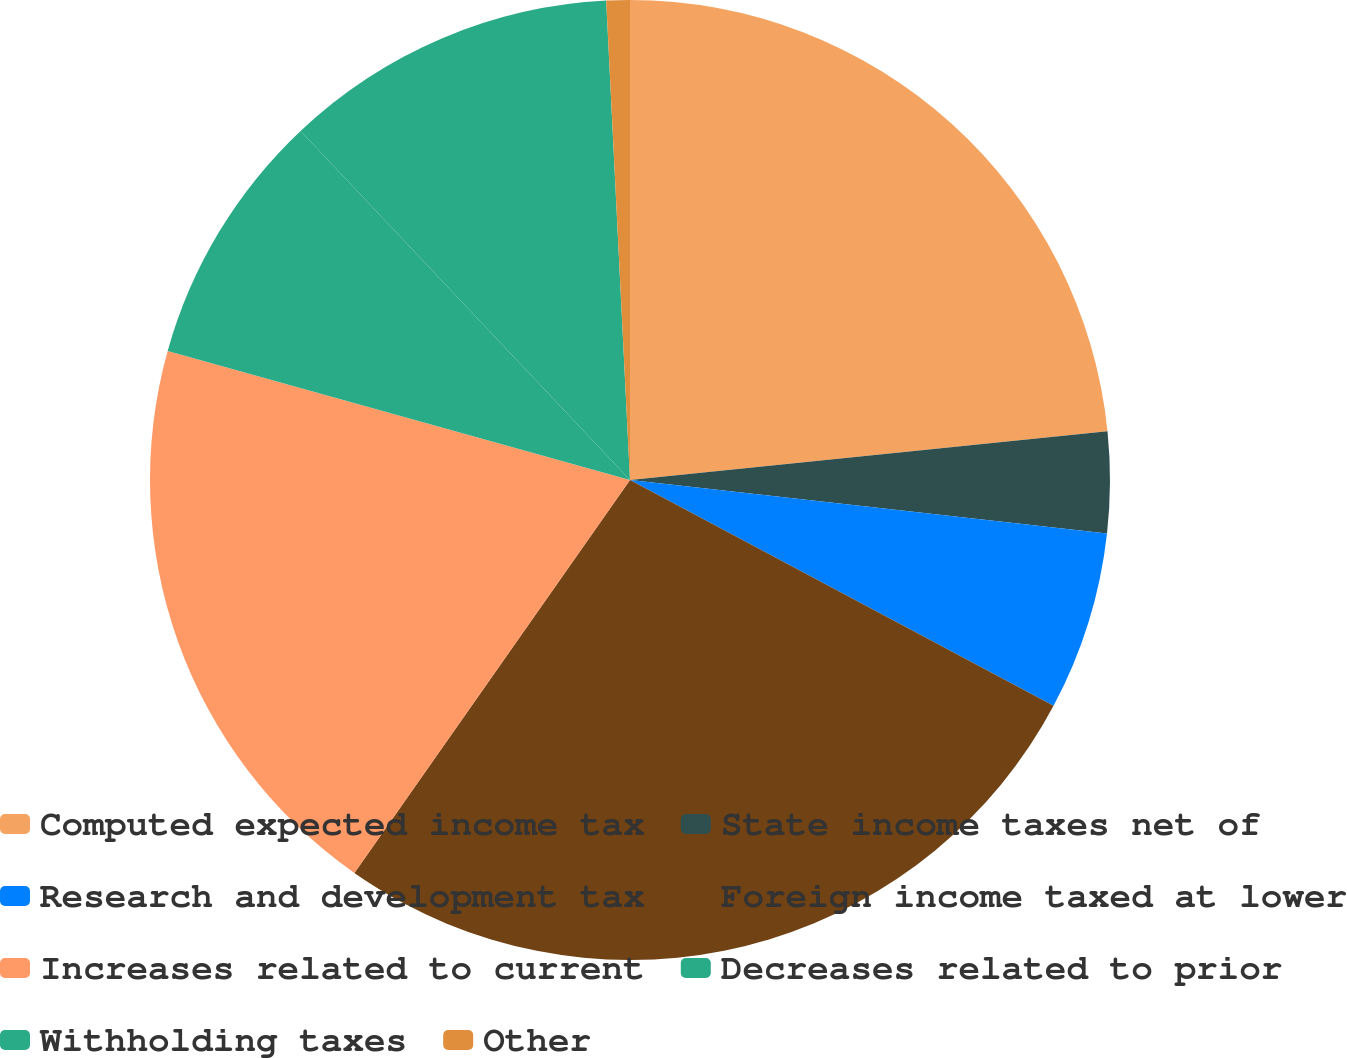Convert chart. <chart><loc_0><loc_0><loc_500><loc_500><pie_chart><fcel>Computed expected income tax<fcel>State income taxes net of<fcel>Research and development tax<fcel>Foreign income taxed at lower<fcel>Increases related to current<fcel>Decreases related to prior<fcel>Withholding taxes<fcel>Other<nl><fcel>23.38%<fcel>3.4%<fcel>6.02%<fcel>26.94%<fcel>19.6%<fcel>8.63%<fcel>11.25%<fcel>0.79%<nl></chart> 